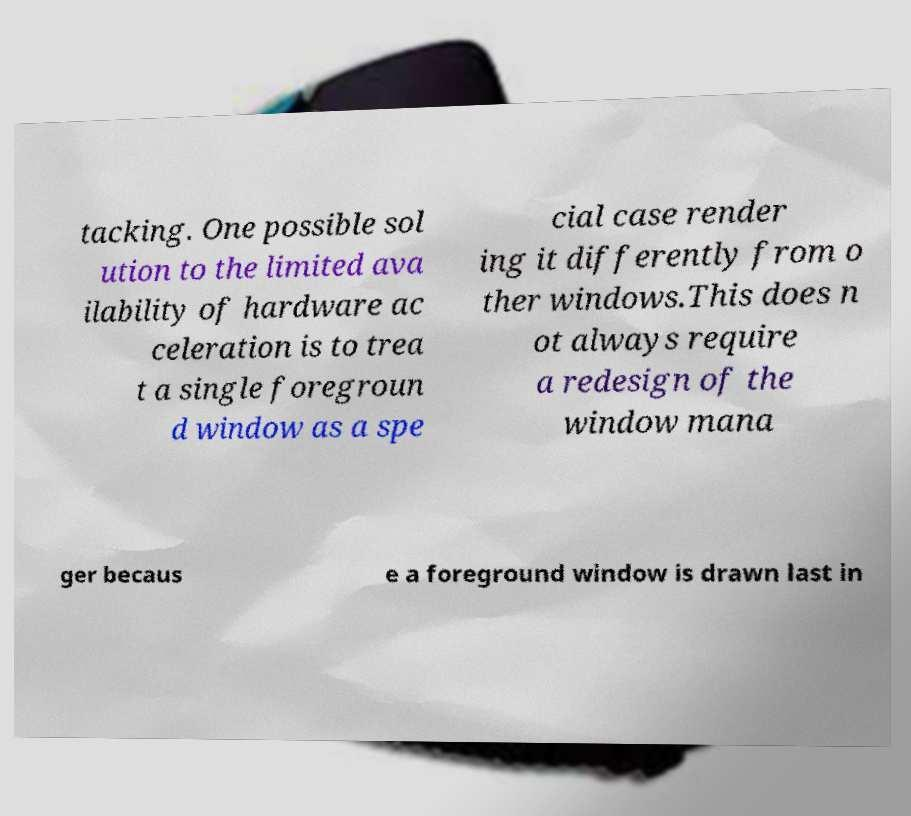Could you assist in decoding the text presented in this image and type it out clearly? tacking. One possible sol ution to the limited ava ilability of hardware ac celeration is to trea t a single foregroun d window as a spe cial case render ing it differently from o ther windows.This does n ot always require a redesign of the window mana ger becaus e a foreground window is drawn last in 